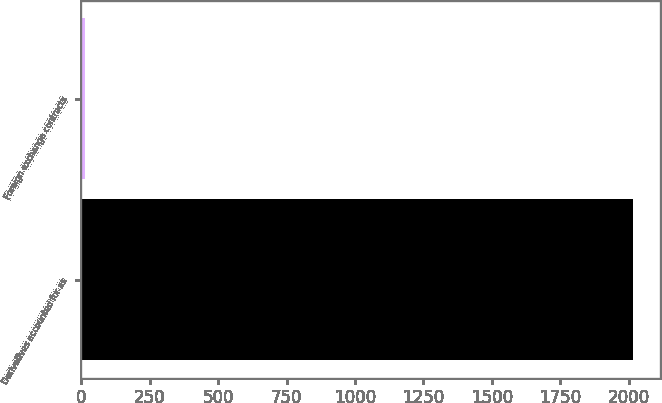<chart> <loc_0><loc_0><loc_500><loc_500><bar_chart><fcel>Derivatives accounted for as<fcel>Foreign exchange contracts<nl><fcel>2015<fcel>13<nl></chart> 